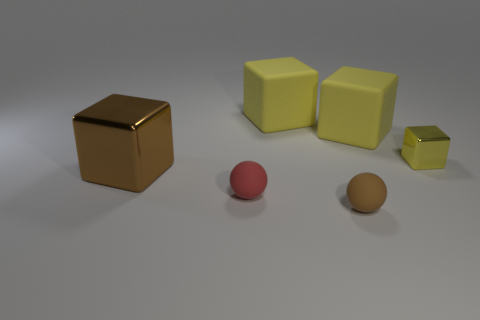Subtract all gray cylinders. How many yellow blocks are left? 3 Subtract 1 cubes. How many cubes are left? 3 Add 4 small rubber balls. How many objects exist? 10 Subtract all balls. How many objects are left? 4 Add 5 tiny matte things. How many tiny matte things exist? 7 Subtract 0 cyan spheres. How many objects are left? 6 Subtract all tiny objects. Subtract all matte cubes. How many objects are left? 1 Add 6 small yellow blocks. How many small yellow blocks are left? 7 